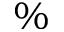Convert formula to latex. <formula><loc_0><loc_0><loc_500><loc_500>\%</formula> 